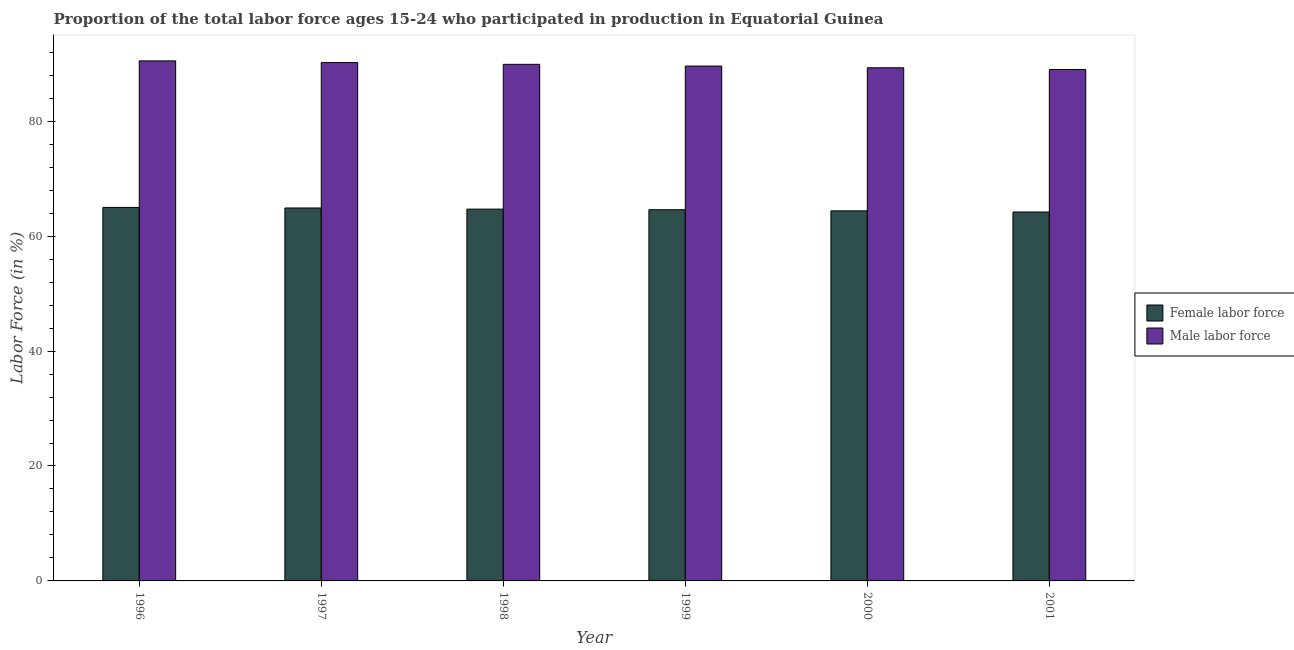How many different coloured bars are there?
Your answer should be compact. 2. How many bars are there on the 5th tick from the left?
Provide a succinct answer. 2. How many bars are there on the 3rd tick from the right?
Your response must be concise. 2. What is the label of the 3rd group of bars from the left?
Provide a succinct answer. 1998. In how many cases, is the number of bars for a given year not equal to the number of legend labels?
Give a very brief answer. 0. What is the percentage of male labour force in 1999?
Keep it short and to the point. 89.6. Across all years, what is the maximum percentage of male labour force?
Keep it short and to the point. 90.5. Across all years, what is the minimum percentage of female labor force?
Provide a short and direct response. 64.2. In which year was the percentage of male labour force minimum?
Keep it short and to the point. 2001. What is the total percentage of female labor force in the graph?
Keep it short and to the point. 387.8. What is the difference between the percentage of male labour force in 1998 and that in 2000?
Give a very brief answer. 0.6. What is the difference between the percentage of female labor force in 1996 and the percentage of male labour force in 1998?
Your answer should be compact. 0.3. What is the average percentage of female labor force per year?
Offer a terse response. 64.63. In how many years, is the percentage of male labour force greater than 56 %?
Provide a short and direct response. 6. What is the ratio of the percentage of male labour force in 2000 to that in 2001?
Keep it short and to the point. 1. Is the percentage of male labour force in 1998 less than that in 1999?
Provide a succinct answer. No. What is the difference between the highest and the second highest percentage of female labor force?
Keep it short and to the point. 0.1. What is the difference between the highest and the lowest percentage of female labor force?
Your response must be concise. 0.8. In how many years, is the percentage of female labor force greater than the average percentage of female labor force taken over all years?
Offer a terse response. 3. Is the sum of the percentage of female labor force in 2000 and 2001 greater than the maximum percentage of male labour force across all years?
Make the answer very short. Yes. What does the 2nd bar from the left in 1999 represents?
Ensure brevity in your answer.  Male labor force. What does the 1st bar from the right in 2000 represents?
Keep it short and to the point. Male labor force. Are all the bars in the graph horizontal?
Ensure brevity in your answer.  No. How many years are there in the graph?
Your answer should be compact. 6. Are the values on the major ticks of Y-axis written in scientific E-notation?
Offer a terse response. No. Does the graph contain grids?
Provide a short and direct response. No. Where does the legend appear in the graph?
Make the answer very short. Center right. What is the title of the graph?
Offer a very short reply. Proportion of the total labor force ages 15-24 who participated in production in Equatorial Guinea. What is the label or title of the Y-axis?
Make the answer very short. Labor Force (in %). What is the Labor Force (in %) of Female labor force in 1996?
Keep it short and to the point. 65. What is the Labor Force (in %) in Male labor force in 1996?
Your answer should be compact. 90.5. What is the Labor Force (in %) of Female labor force in 1997?
Offer a terse response. 64.9. What is the Labor Force (in %) in Male labor force in 1997?
Your answer should be very brief. 90.2. What is the Labor Force (in %) of Female labor force in 1998?
Your answer should be very brief. 64.7. What is the Labor Force (in %) of Male labor force in 1998?
Keep it short and to the point. 89.9. What is the Labor Force (in %) in Female labor force in 1999?
Provide a short and direct response. 64.6. What is the Labor Force (in %) in Male labor force in 1999?
Keep it short and to the point. 89.6. What is the Labor Force (in %) of Female labor force in 2000?
Provide a short and direct response. 64.4. What is the Labor Force (in %) in Male labor force in 2000?
Your answer should be compact. 89.3. What is the Labor Force (in %) in Female labor force in 2001?
Provide a succinct answer. 64.2. What is the Labor Force (in %) of Male labor force in 2001?
Give a very brief answer. 89. Across all years, what is the maximum Labor Force (in %) in Male labor force?
Make the answer very short. 90.5. Across all years, what is the minimum Labor Force (in %) in Female labor force?
Make the answer very short. 64.2. Across all years, what is the minimum Labor Force (in %) of Male labor force?
Provide a short and direct response. 89. What is the total Labor Force (in %) in Female labor force in the graph?
Provide a succinct answer. 387.8. What is the total Labor Force (in %) in Male labor force in the graph?
Your answer should be compact. 538.5. What is the difference between the Labor Force (in %) of Female labor force in 1996 and that in 1997?
Offer a terse response. 0.1. What is the difference between the Labor Force (in %) of Female labor force in 1996 and that in 1998?
Ensure brevity in your answer.  0.3. What is the difference between the Labor Force (in %) in Male labor force in 1996 and that in 1998?
Your response must be concise. 0.6. What is the difference between the Labor Force (in %) of Female labor force in 1996 and that in 2000?
Make the answer very short. 0.6. What is the difference between the Labor Force (in %) in Male labor force in 1996 and that in 2000?
Your answer should be compact. 1.2. What is the difference between the Labor Force (in %) in Female labor force in 1997 and that in 1998?
Offer a terse response. 0.2. What is the difference between the Labor Force (in %) in Male labor force in 1997 and that in 1998?
Offer a very short reply. 0.3. What is the difference between the Labor Force (in %) in Female labor force in 1997 and that in 1999?
Keep it short and to the point. 0.3. What is the difference between the Labor Force (in %) in Female labor force in 1997 and that in 2000?
Give a very brief answer. 0.5. What is the difference between the Labor Force (in %) of Male labor force in 1997 and that in 2000?
Make the answer very short. 0.9. What is the difference between the Labor Force (in %) of Male labor force in 1997 and that in 2001?
Provide a succinct answer. 1.2. What is the difference between the Labor Force (in %) of Female labor force in 1998 and that in 1999?
Offer a terse response. 0.1. What is the difference between the Labor Force (in %) of Male labor force in 1998 and that in 2000?
Give a very brief answer. 0.6. What is the difference between the Labor Force (in %) in Male labor force in 1999 and that in 2000?
Provide a short and direct response. 0.3. What is the difference between the Labor Force (in %) in Female labor force in 1999 and that in 2001?
Give a very brief answer. 0.4. What is the difference between the Labor Force (in %) of Male labor force in 1999 and that in 2001?
Offer a terse response. 0.6. What is the difference between the Labor Force (in %) in Male labor force in 2000 and that in 2001?
Your response must be concise. 0.3. What is the difference between the Labor Force (in %) of Female labor force in 1996 and the Labor Force (in %) of Male labor force in 1997?
Your answer should be compact. -25.2. What is the difference between the Labor Force (in %) of Female labor force in 1996 and the Labor Force (in %) of Male labor force in 1998?
Provide a succinct answer. -24.9. What is the difference between the Labor Force (in %) in Female labor force in 1996 and the Labor Force (in %) in Male labor force in 1999?
Your answer should be compact. -24.6. What is the difference between the Labor Force (in %) of Female labor force in 1996 and the Labor Force (in %) of Male labor force in 2000?
Keep it short and to the point. -24.3. What is the difference between the Labor Force (in %) in Female labor force in 1996 and the Labor Force (in %) in Male labor force in 2001?
Ensure brevity in your answer.  -24. What is the difference between the Labor Force (in %) of Female labor force in 1997 and the Labor Force (in %) of Male labor force in 1999?
Your answer should be very brief. -24.7. What is the difference between the Labor Force (in %) in Female labor force in 1997 and the Labor Force (in %) in Male labor force in 2000?
Keep it short and to the point. -24.4. What is the difference between the Labor Force (in %) in Female labor force in 1997 and the Labor Force (in %) in Male labor force in 2001?
Offer a very short reply. -24.1. What is the difference between the Labor Force (in %) in Female labor force in 1998 and the Labor Force (in %) in Male labor force in 1999?
Offer a very short reply. -24.9. What is the difference between the Labor Force (in %) of Female labor force in 1998 and the Labor Force (in %) of Male labor force in 2000?
Offer a terse response. -24.6. What is the difference between the Labor Force (in %) in Female labor force in 1998 and the Labor Force (in %) in Male labor force in 2001?
Your answer should be compact. -24.3. What is the difference between the Labor Force (in %) in Female labor force in 1999 and the Labor Force (in %) in Male labor force in 2000?
Provide a short and direct response. -24.7. What is the difference between the Labor Force (in %) in Female labor force in 1999 and the Labor Force (in %) in Male labor force in 2001?
Keep it short and to the point. -24.4. What is the difference between the Labor Force (in %) in Female labor force in 2000 and the Labor Force (in %) in Male labor force in 2001?
Your answer should be very brief. -24.6. What is the average Labor Force (in %) in Female labor force per year?
Give a very brief answer. 64.63. What is the average Labor Force (in %) in Male labor force per year?
Make the answer very short. 89.75. In the year 1996, what is the difference between the Labor Force (in %) of Female labor force and Labor Force (in %) of Male labor force?
Offer a very short reply. -25.5. In the year 1997, what is the difference between the Labor Force (in %) of Female labor force and Labor Force (in %) of Male labor force?
Your answer should be very brief. -25.3. In the year 1998, what is the difference between the Labor Force (in %) of Female labor force and Labor Force (in %) of Male labor force?
Give a very brief answer. -25.2. In the year 2000, what is the difference between the Labor Force (in %) of Female labor force and Labor Force (in %) of Male labor force?
Provide a succinct answer. -24.9. In the year 2001, what is the difference between the Labor Force (in %) in Female labor force and Labor Force (in %) in Male labor force?
Offer a very short reply. -24.8. What is the ratio of the Labor Force (in %) in Female labor force in 1996 to that in 1997?
Keep it short and to the point. 1. What is the ratio of the Labor Force (in %) of Female labor force in 1996 to that in 1998?
Offer a terse response. 1. What is the ratio of the Labor Force (in %) of Male labor force in 1996 to that in 1998?
Your answer should be compact. 1.01. What is the ratio of the Labor Force (in %) of Female labor force in 1996 to that in 2000?
Provide a short and direct response. 1.01. What is the ratio of the Labor Force (in %) in Male labor force in 1996 to that in 2000?
Your response must be concise. 1.01. What is the ratio of the Labor Force (in %) in Female labor force in 1996 to that in 2001?
Provide a short and direct response. 1.01. What is the ratio of the Labor Force (in %) of Male labor force in 1996 to that in 2001?
Give a very brief answer. 1.02. What is the ratio of the Labor Force (in %) of Female labor force in 1997 to that in 1998?
Ensure brevity in your answer.  1. What is the ratio of the Labor Force (in %) in Female labor force in 1997 to that in 2000?
Offer a very short reply. 1.01. What is the ratio of the Labor Force (in %) of Male labor force in 1997 to that in 2000?
Ensure brevity in your answer.  1.01. What is the ratio of the Labor Force (in %) in Female labor force in 1997 to that in 2001?
Provide a short and direct response. 1.01. What is the ratio of the Labor Force (in %) of Male labor force in 1997 to that in 2001?
Give a very brief answer. 1.01. What is the ratio of the Labor Force (in %) in Female labor force in 1998 to that in 1999?
Keep it short and to the point. 1. What is the ratio of the Labor Force (in %) of Male labor force in 1998 to that in 1999?
Offer a terse response. 1. What is the ratio of the Labor Force (in %) in Female labor force in 1998 to that in 2000?
Give a very brief answer. 1. What is the ratio of the Labor Force (in %) of Female labor force in 1999 to that in 2000?
Offer a very short reply. 1. What is the ratio of the Labor Force (in %) of Female labor force in 1999 to that in 2001?
Provide a succinct answer. 1.01. What is the ratio of the Labor Force (in %) in Male labor force in 1999 to that in 2001?
Keep it short and to the point. 1.01. What is the ratio of the Labor Force (in %) of Female labor force in 2000 to that in 2001?
Your response must be concise. 1. What is the difference between the highest and the second highest Labor Force (in %) of Female labor force?
Provide a succinct answer. 0.1. What is the difference between the highest and the lowest Labor Force (in %) in Male labor force?
Your answer should be compact. 1.5. 